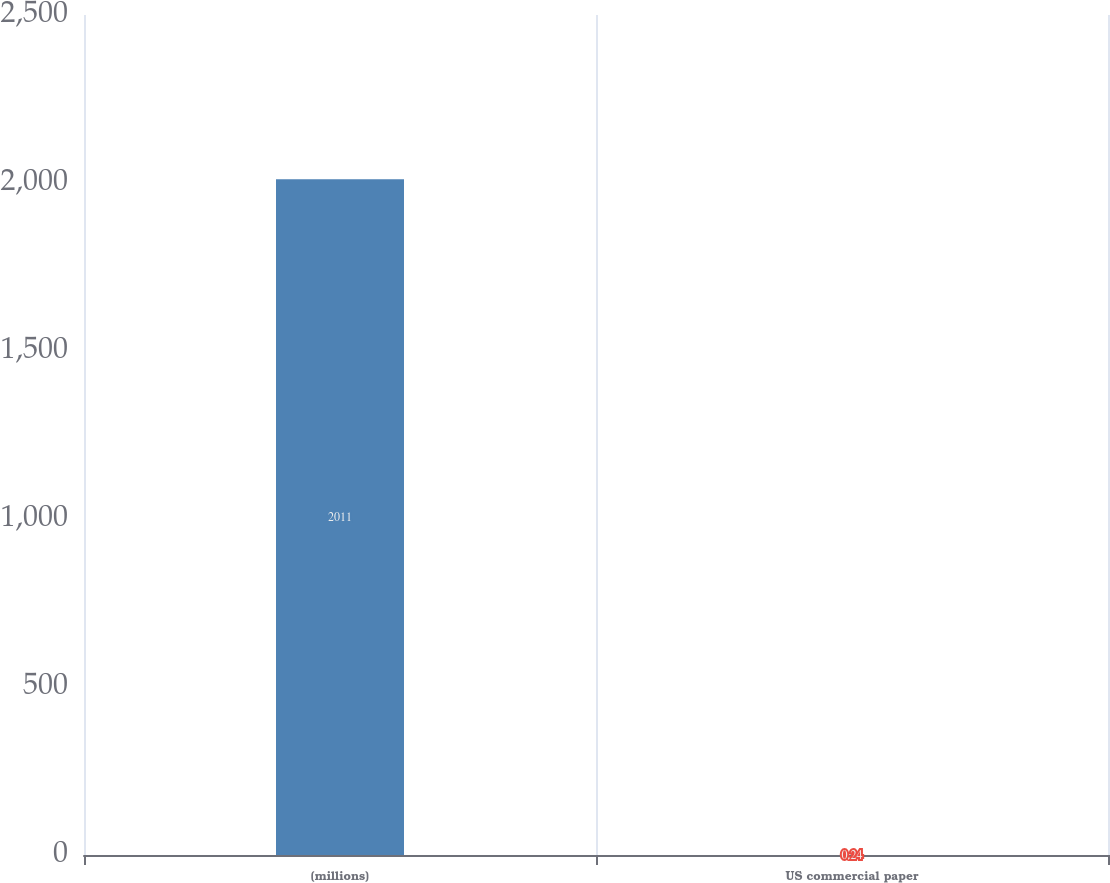<chart> <loc_0><loc_0><loc_500><loc_500><bar_chart><fcel>(millions)<fcel>US commercial paper<nl><fcel>2011<fcel>0.24<nl></chart> 